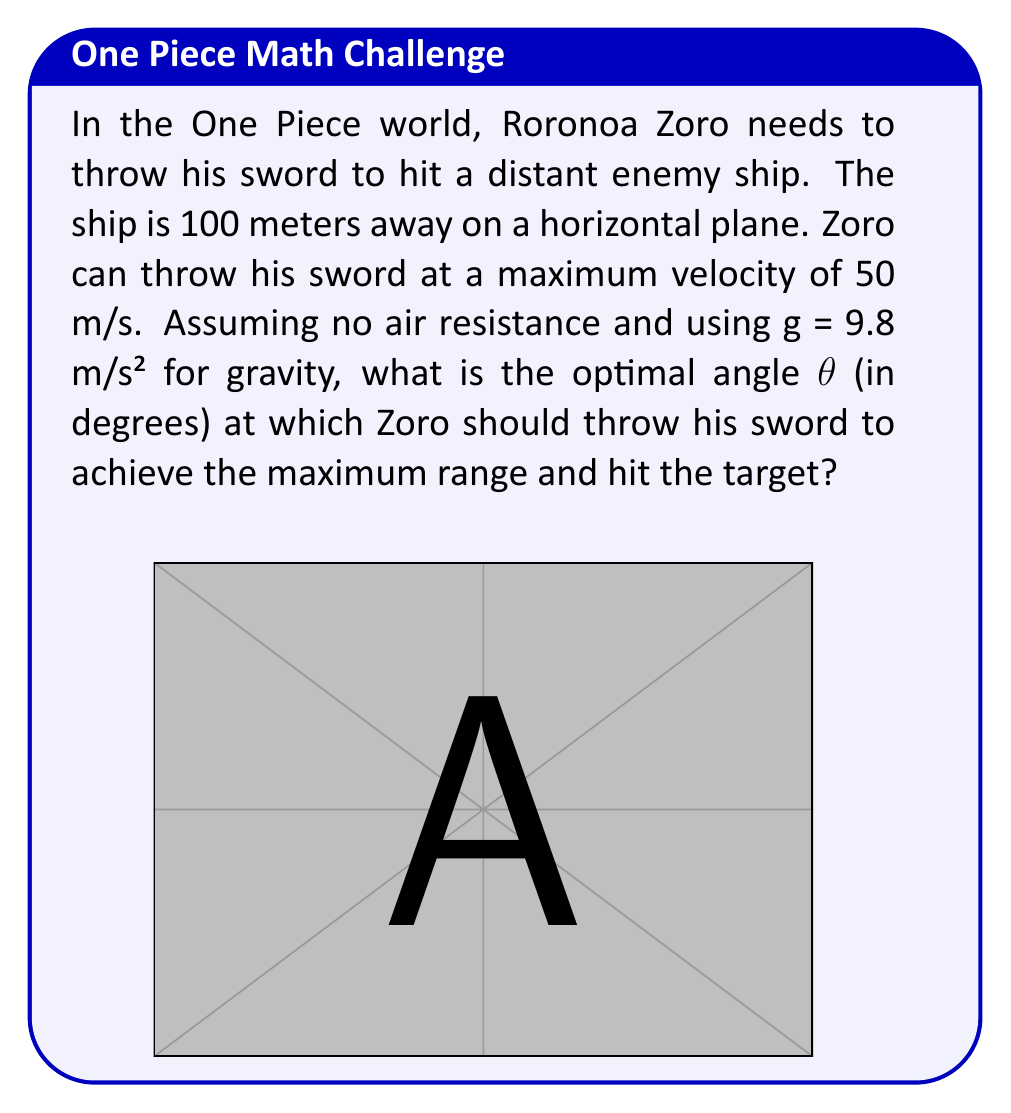Show me your answer to this math problem. To solve this problem, we'll use the range equation for projectile motion and maximize it to find the optimal angle:

1) The range equation for a projectile launched from ground level is:

   $$R = \frac{v_0^2 \sin(2\theta)}{g}$$

   Where $R$ is the range, $v_0$ is the initial velocity, $\theta$ is the launch angle, and $g$ is the acceleration due to gravity.

2) We want to maximize this equation. The maximum value of $\sin(2\theta)$ occurs when $2\theta = 90°$ or $\theta = 45°$.

3) Therefore, the optimal angle for maximum range is always 45° in the absence of air resistance.

4) We can verify this by calculating the range at 45°:

   $$R = \frac{(50 \text{ m/s})^2 \sin(2 \cdot 45°)}{9.8 \text{ m/s}^2}$$

   $$R = \frac{2500 \cdot 1}{9.8} \text{ m} \approx 255.1 \text{ m}$$

5) This range is greater than the required 100 meters, so Zoro can indeed hit the target at this angle.

In the One Piece world, Zoro's exceptional strength allows him to throw his sword at such high velocities, making this feat possible!
Answer: The optimal angle for Zoro to throw his sword is $45°$. 